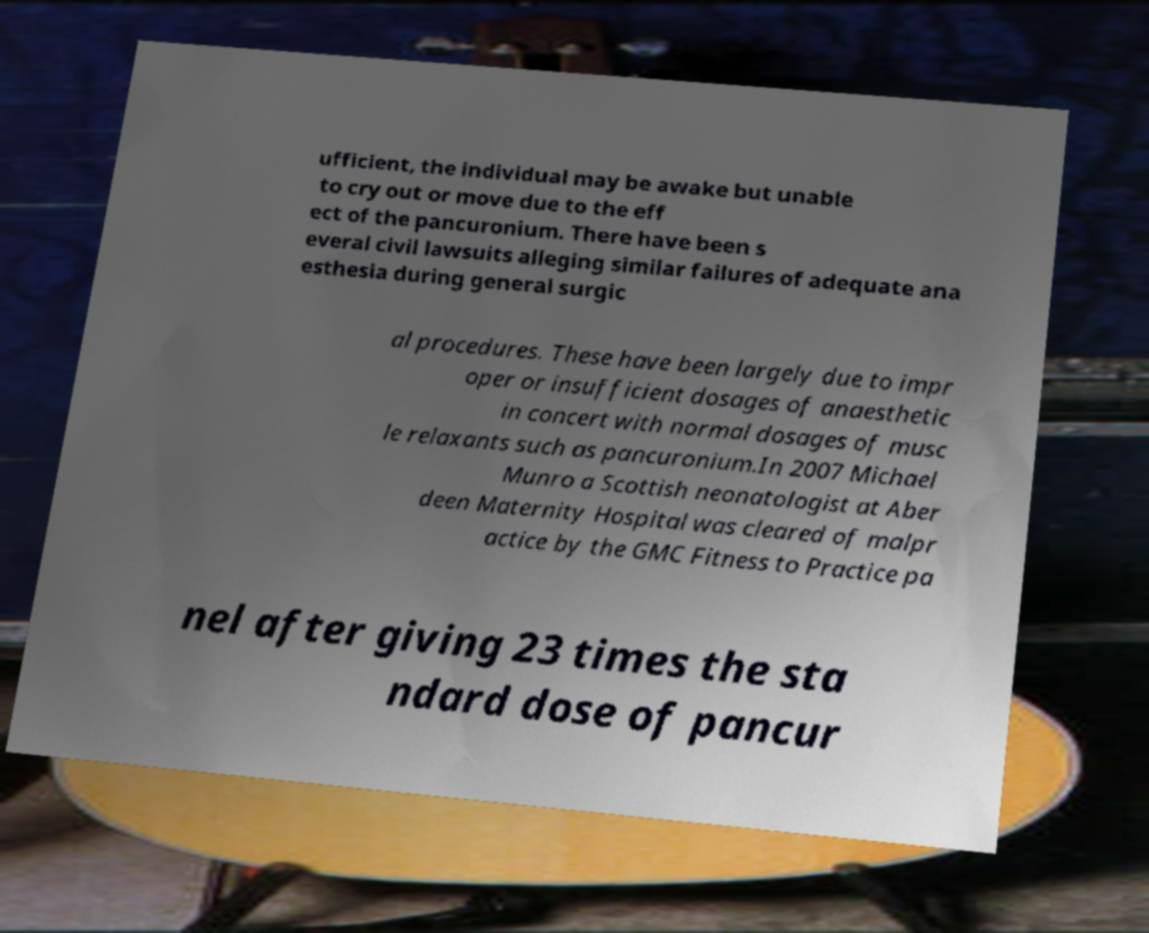Could you extract and type out the text from this image? ufficient, the individual may be awake but unable to cry out or move due to the eff ect of the pancuronium. There have been s everal civil lawsuits alleging similar failures of adequate ana esthesia during general surgic al procedures. These have been largely due to impr oper or insufficient dosages of anaesthetic in concert with normal dosages of musc le relaxants such as pancuronium.In 2007 Michael Munro a Scottish neonatologist at Aber deen Maternity Hospital was cleared of malpr actice by the GMC Fitness to Practice pa nel after giving 23 times the sta ndard dose of pancur 